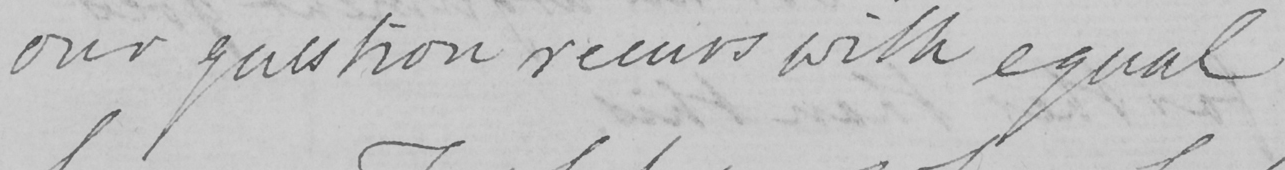Can you read and transcribe this handwriting? our question recurs with equal 